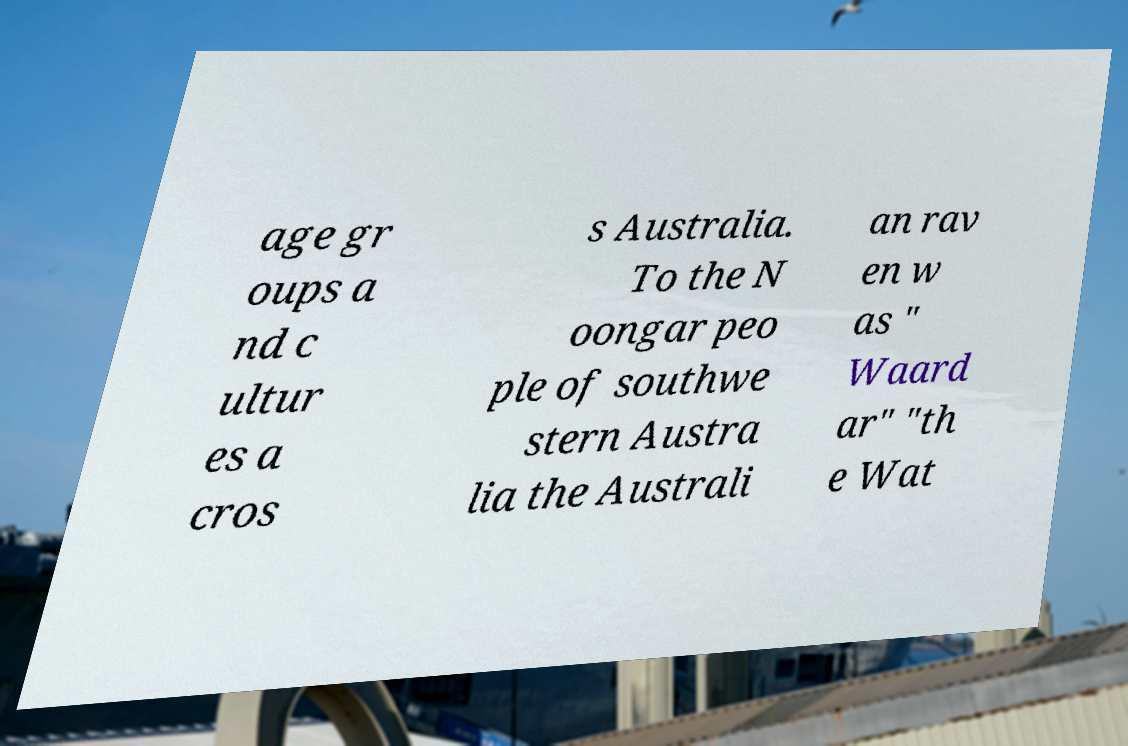What messages or text are displayed in this image? I need them in a readable, typed format. age gr oups a nd c ultur es a cros s Australia. To the N oongar peo ple of southwe stern Austra lia the Australi an rav en w as " Waard ar" "th e Wat 